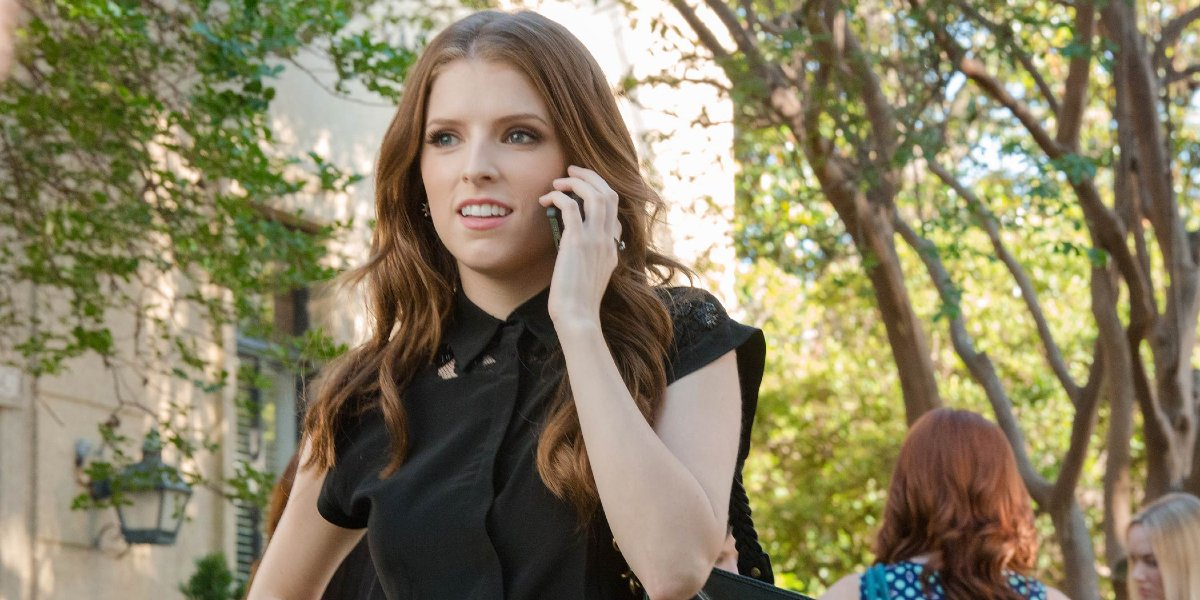Describe the setting surrounding the woman. The woman is walking down a serene, tree-lined street. The trees' branches arch overhead, creating a picturesque canopy that filters the sunlight, casting soft, dappled shadows on the sidewalk. The street is calm, with a few more people visible in the background, all adding to the setting's tranquil ambiance. Nearby buildings, with their cozy, inviting facades, enhance the scene's charm and everyday feel. How does the setting contribute to the overall mood of the image? The setting plays a significant role in creating a peaceful and reflective mood. The gentle light filtering through the trees and the quiet street suggest a moment of calm amidst the woman’s busy day. This serene backdrop contrasts with her worried expression, emphasizing the personal concern she feels. It’s a snapshot that balances tranquility with the subtle tension of her conversation. Can you imagine an ideal storyline about her day based on this image? Sure! After a hectic morning of meetings, she decided to take a stroll to clear her mind and catch up on calls. She started with a warm chat with her mom, light-hearted and comforting. But then, she received an unexpected call from her best friend, sharing some troubling news. Now, as she walks this peaceful street, she’s trying to offer advice and be there for her friend, all while mentally preparing for the rest of her busy day. Amidst it all, this walk and the beautiful surroundings are her few moments of respite. 